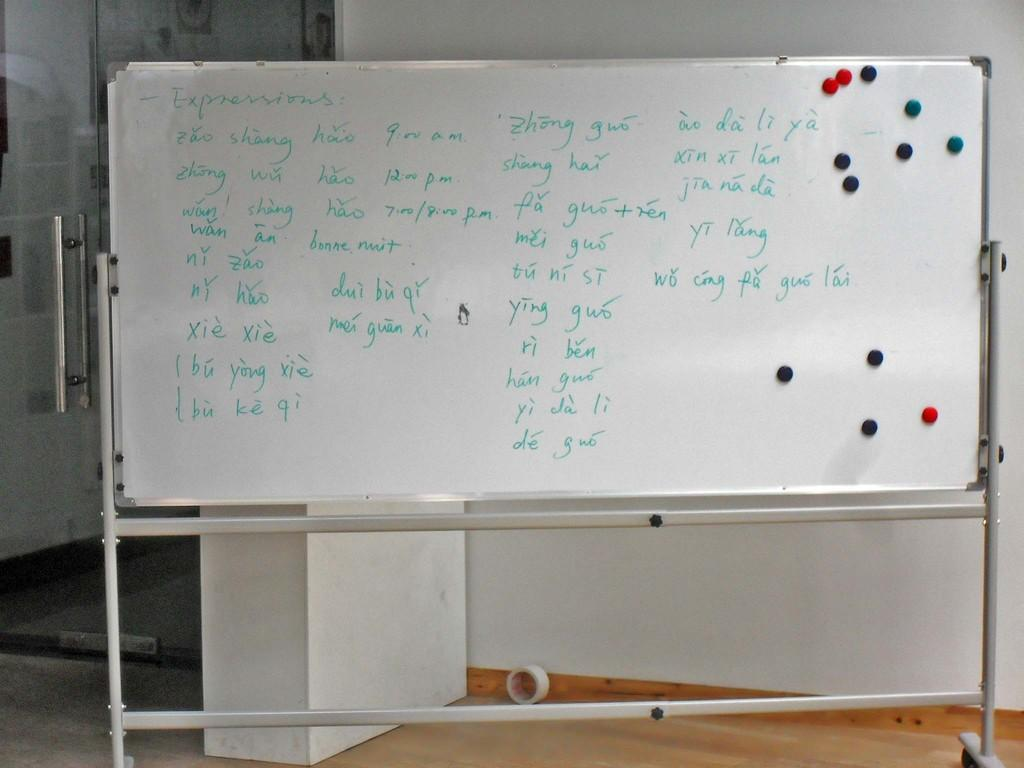<image>
Give a short and clear explanation of the subsequent image. A white board with Expressions written on it and a bunch of categories under it. 